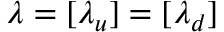Convert formula to latex. <formula><loc_0><loc_0><loc_500><loc_500>\lambda = [ \lambda _ { u } ] = [ \lambda _ { d } ]</formula> 